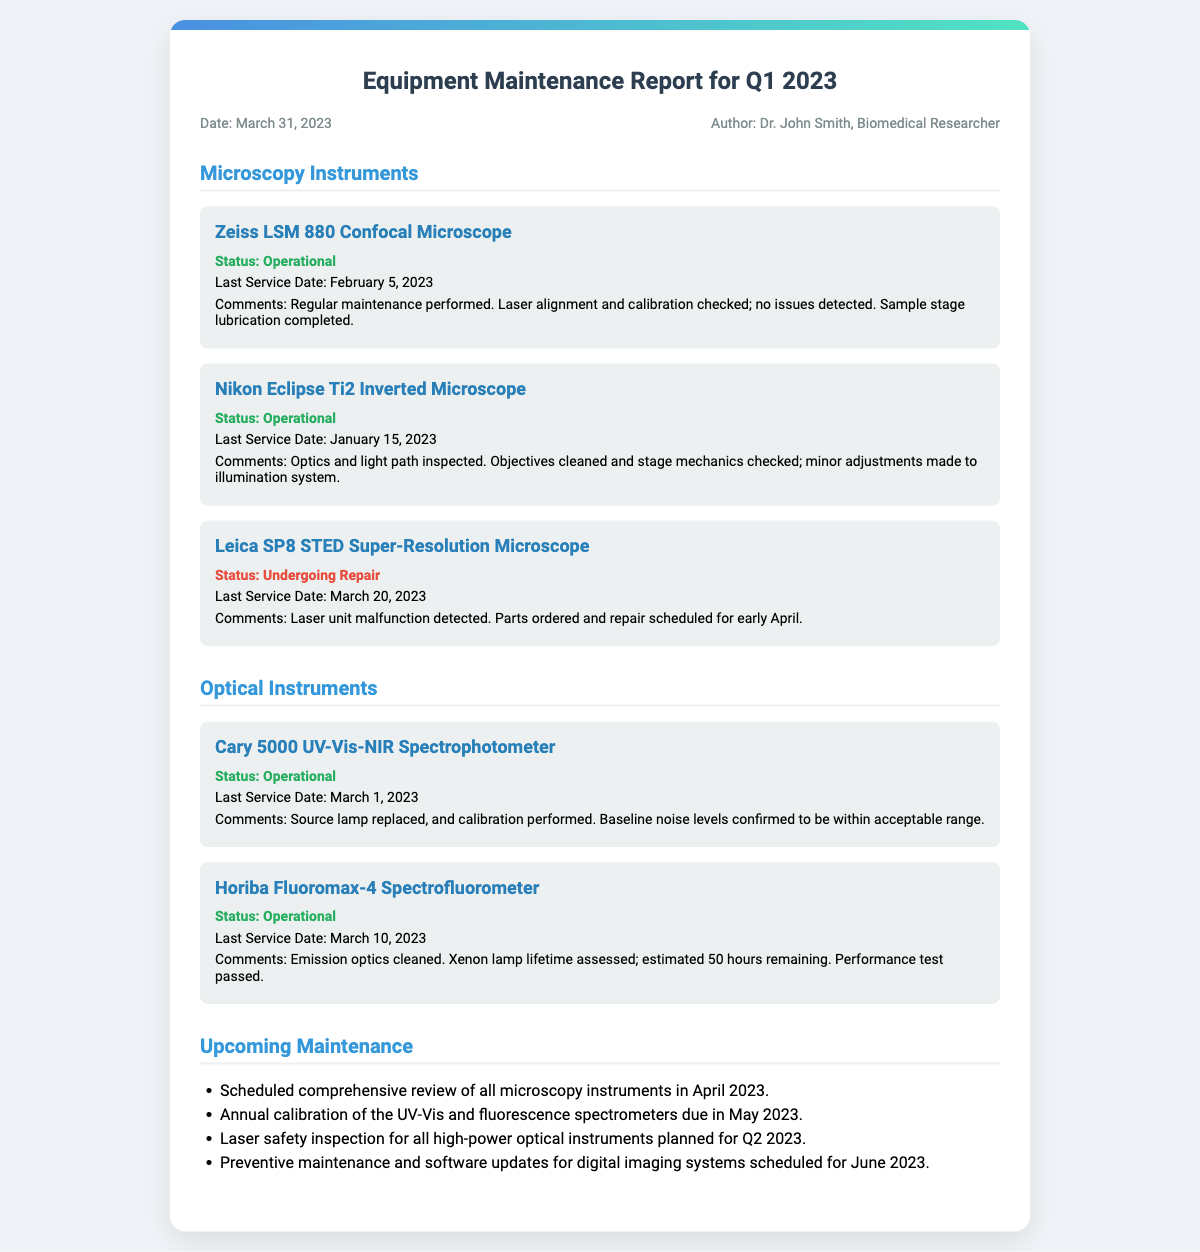What is the date of the report? The date of the report is mentioned in the meta section of the document.
Answer: March 31, 2023 Who authored the report? The author of the report is specified right below the date in the meta section.
Answer: Dr. John Smith, Biomedical Researcher What is the status of the Zeiss LSM 880 Confocal Microscope? The status of each instrument is indicated clearly in the respective sections.
Answer: Operational When was the last service for the Leica SP8 STED Super-Resolution Microscope? The last service date can be found under the comments section for the specific instrument.
Answer: March 20, 2023 What parts are needed for the Leica SP8 STED Super-Resolution Microscope? The comments section mentions the need for parts ordered for the instrument undergoing repair.
Answer: Parts ordered When is the scheduled maintenance for all microscopy instruments? The upcoming maintenance section lists the timing of the scheduled comprehensive review.
Answer: April 2023 What maintenance is planned for high-power optical instruments? The document mentions specific inspections planned for a later date in the upcoming maintenance section.
Answer: Laser safety inspection What was replaced in the Cary 5000 UV-Vis-NIR Spectrophotometer? The comment provides specific maintenance actions taken for this instrument.
Answer: Source lamp 